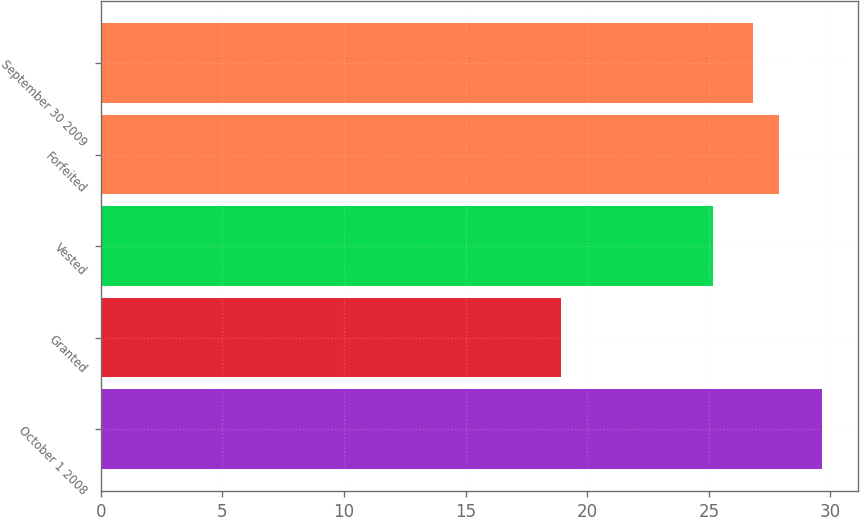<chart> <loc_0><loc_0><loc_500><loc_500><bar_chart><fcel>October 1 2008<fcel>Granted<fcel>Vested<fcel>Forfeited<fcel>September 30 2009<nl><fcel>29.64<fcel>18.91<fcel>25.18<fcel>27.87<fcel>26.8<nl></chart> 